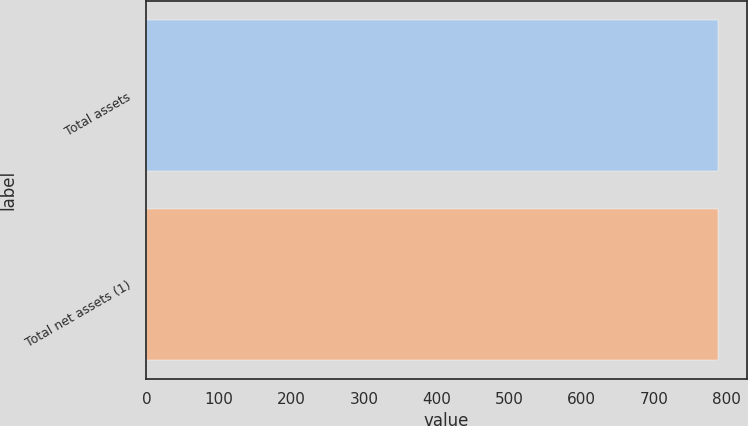Convert chart to OTSL. <chart><loc_0><loc_0><loc_500><loc_500><bar_chart><fcel>Total assets<fcel>Total net assets (1)<nl><fcel>788<fcel>788.1<nl></chart> 